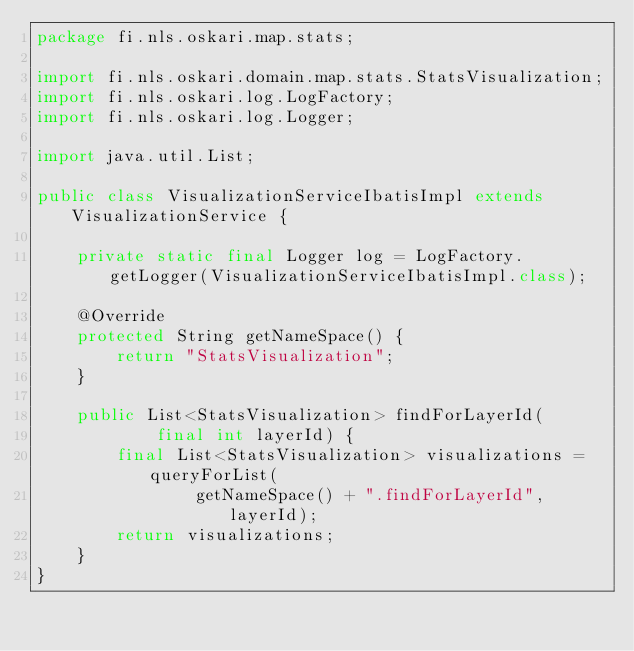<code> <loc_0><loc_0><loc_500><loc_500><_Java_>package fi.nls.oskari.map.stats;

import fi.nls.oskari.domain.map.stats.StatsVisualization;
import fi.nls.oskari.log.LogFactory;
import fi.nls.oskari.log.Logger;

import java.util.List;

public class VisualizationServiceIbatisImpl extends VisualizationService {
    
    private static final Logger log = LogFactory.getLogger(VisualizationServiceIbatisImpl.class);

    @Override
    protected String getNameSpace() {
        return "StatsVisualization";
    }

    public List<StatsVisualization> findForLayerId(
            final int layerId) {
        final List<StatsVisualization> visualizations = queryForList(
                getNameSpace() + ".findForLayerId", layerId);
        return visualizations;
    }
}
</code> 